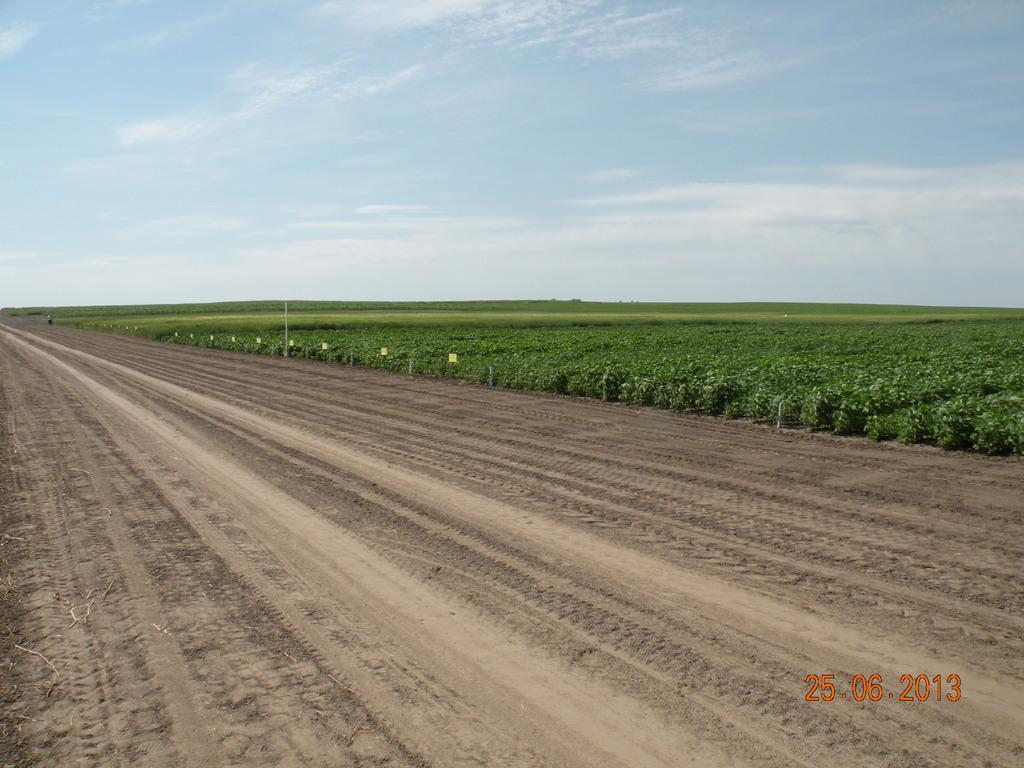What is at the bottom of the image? There is soil at the bottom of the image. What type of vegetation can be seen on the right side of the image? There are bushes on the right side of the image. Where are the numbers located in the image? The numbers are on the right-hand side bottom of the image. What is visible at the top of the image? The sky is visible at the top of the image. What is the opinion of the spoon in the image? There is no spoon present in the image, so it cannot have an opinion. What type of boundary can be seen in the image? There is no boundary visible in the image. 